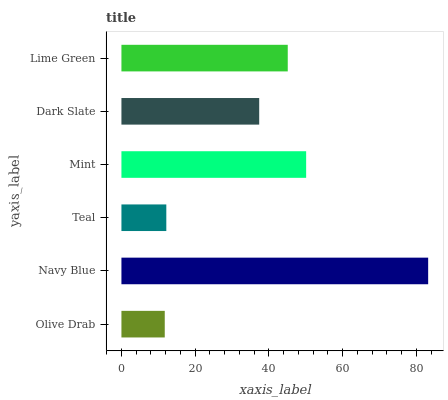Is Olive Drab the minimum?
Answer yes or no. Yes. Is Navy Blue the maximum?
Answer yes or no. Yes. Is Teal the minimum?
Answer yes or no. No. Is Teal the maximum?
Answer yes or no. No. Is Navy Blue greater than Teal?
Answer yes or no. Yes. Is Teal less than Navy Blue?
Answer yes or no. Yes. Is Teal greater than Navy Blue?
Answer yes or no. No. Is Navy Blue less than Teal?
Answer yes or no. No. Is Lime Green the high median?
Answer yes or no. Yes. Is Dark Slate the low median?
Answer yes or no. Yes. Is Olive Drab the high median?
Answer yes or no. No. Is Teal the low median?
Answer yes or no. No. 